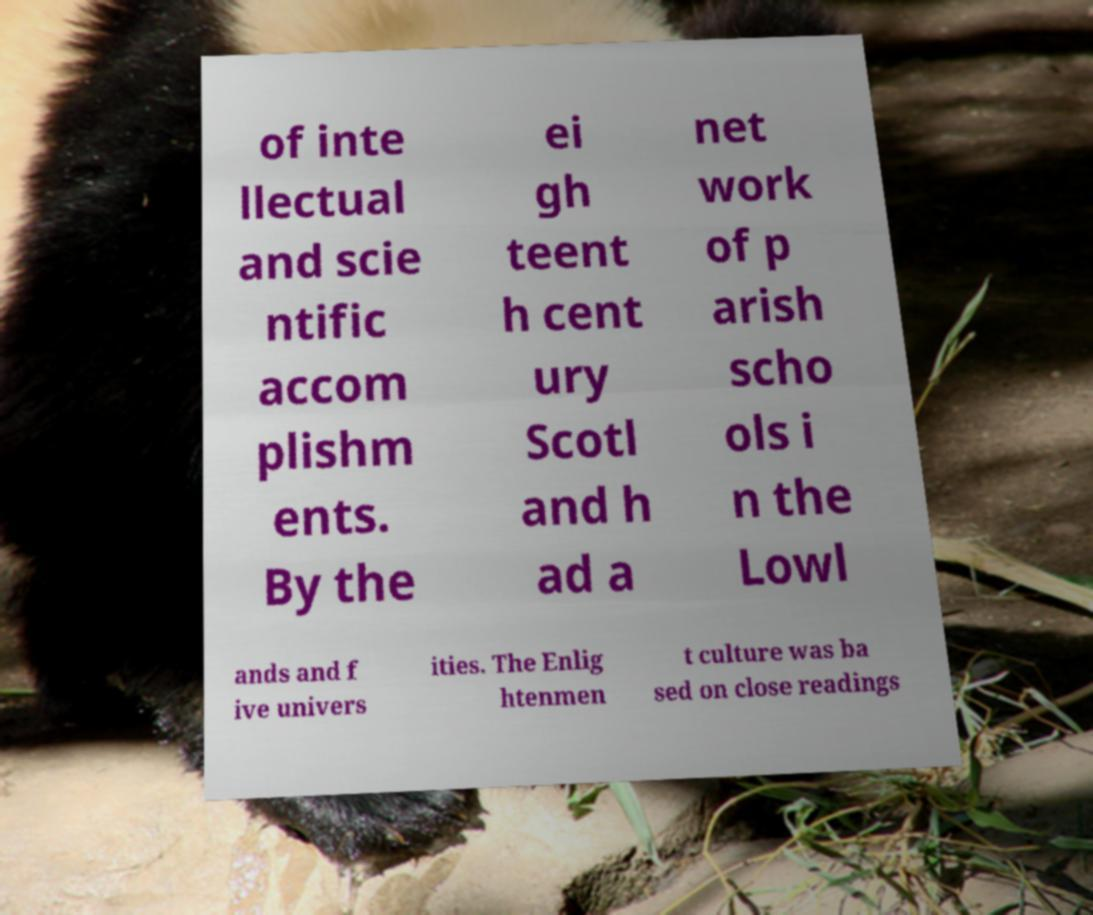Could you extract and type out the text from this image? of inte llectual and scie ntific accom plishm ents. By the ei gh teent h cent ury Scotl and h ad a net work of p arish scho ols i n the Lowl ands and f ive univers ities. The Enlig htenmen t culture was ba sed on close readings 